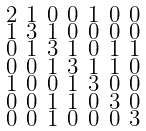Convert formula to latex. <formula><loc_0><loc_0><loc_500><loc_500>\begin{smallmatrix} 2 & 1 & 0 & 0 & 1 & 0 & 0 \\ 1 & 3 & 1 & 0 & 0 & 0 & 0 \\ 0 & 1 & 3 & 1 & 0 & 1 & 1 \\ 0 & 0 & 1 & 3 & 1 & 1 & 0 \\ 1 & 0 & 0 & 1 & 3 & 0 & 0 \\ 0 & 0 & 1 & 1 & 0 & 3 & 0 \\ 0 & 0 & 1 & 0 & 0 & 0 & 3 \end{smallmatrix}</formula> 